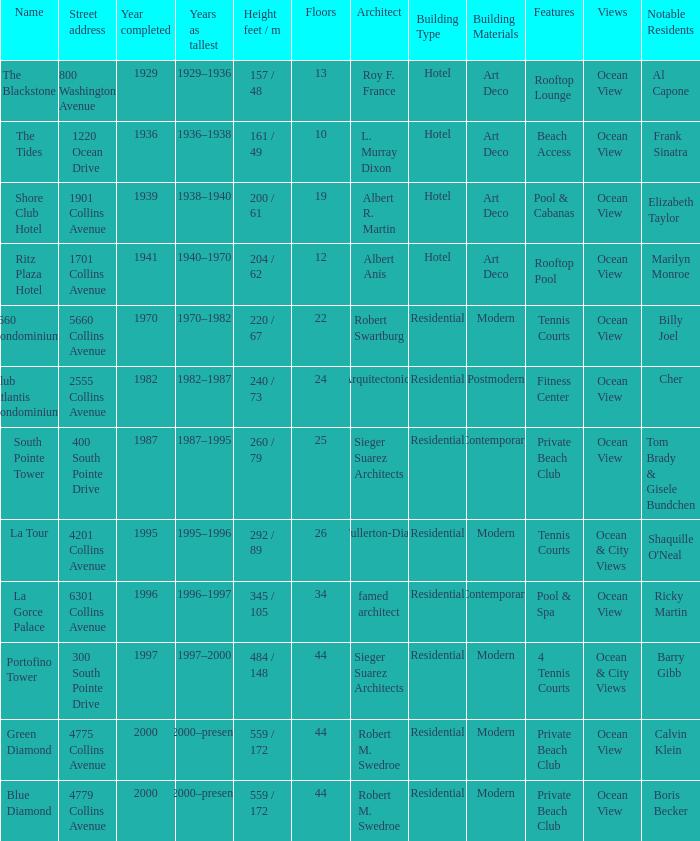What is the height of the Tides with less than 34 floors? 161 / 49. 